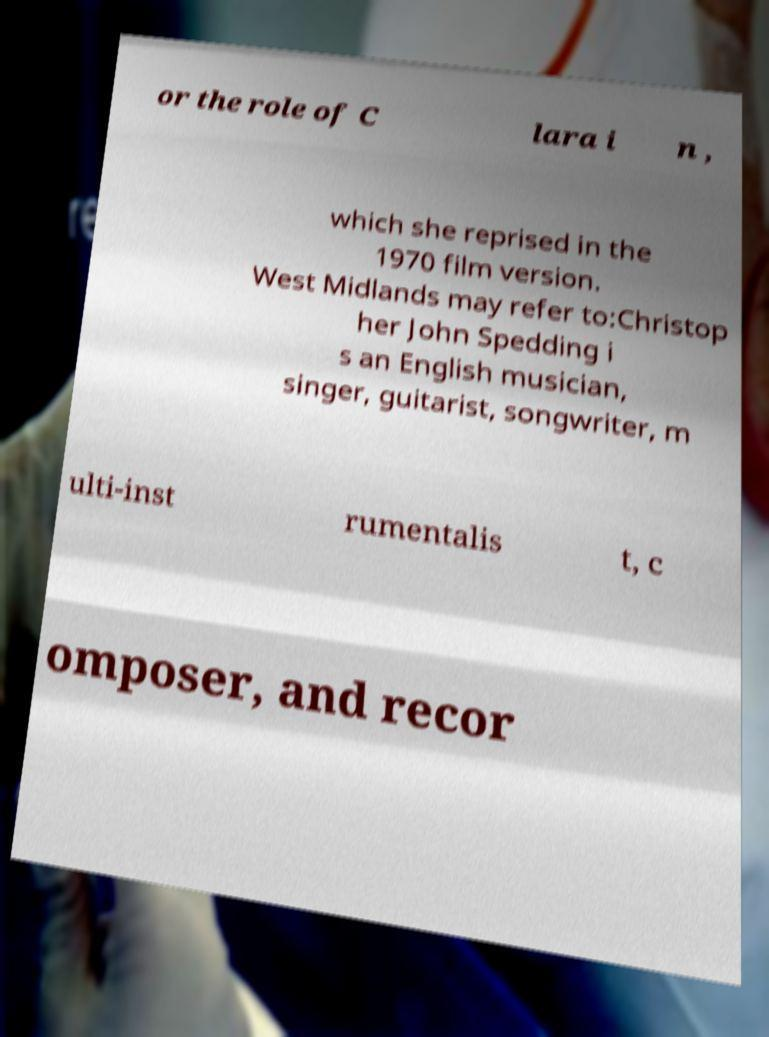Please read and relay the text visible in this image. What does it say? or the role of C lara i n , which she reprised in the 1970 film version. West Midlands may refer to:Christop her John Spedding i s an English musician, singer, guitarist, songwriter, m ulti-inst rumentalis t, c omposer, and recor 